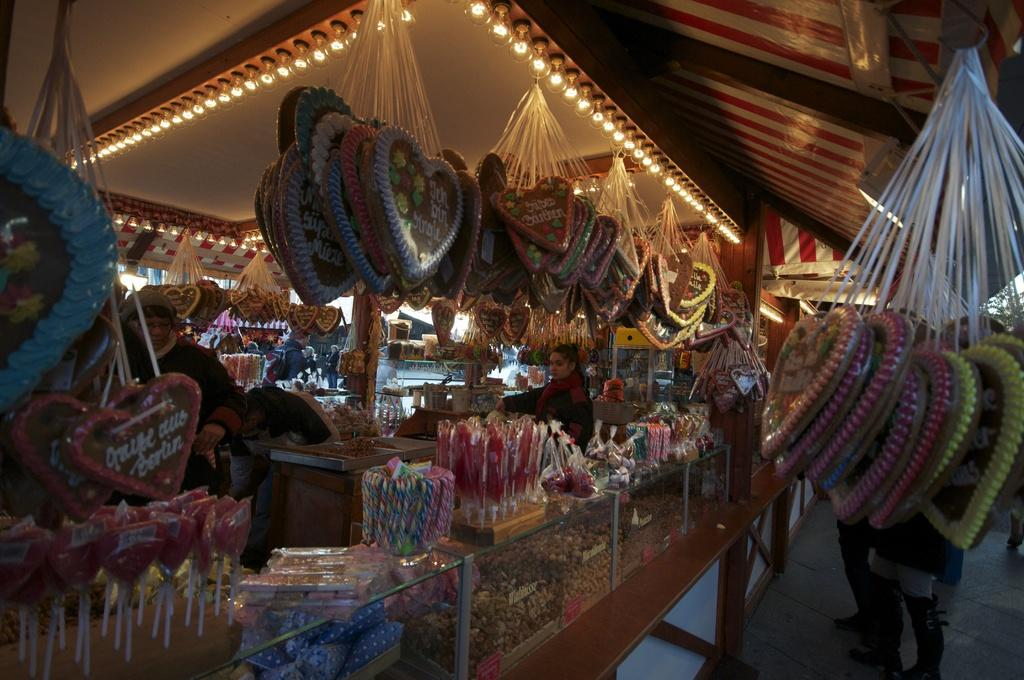What type of establishments can be seen in the image? There are food stalls in the image. What type of sweets are visible in the image? There are candies in the image. How are some of the food items displayed in the image? Some food items are displayed in glass boxes in the image. What can be seen illuminating the area in the image? There are lights in the image. Are there any people present in the image? Yes, there are people in the image. What other objects can be seen in the image besides food-related items? There are other objects in the image. What type of goat is being served as a dish in the image? There is no goat present in the image; it features food stalls, candies, and food items in glass boxes. Who is the partner of the person standing next to the food stall in the image? There is no indication of a partner or any specific person standing next to the food stall in the image. 